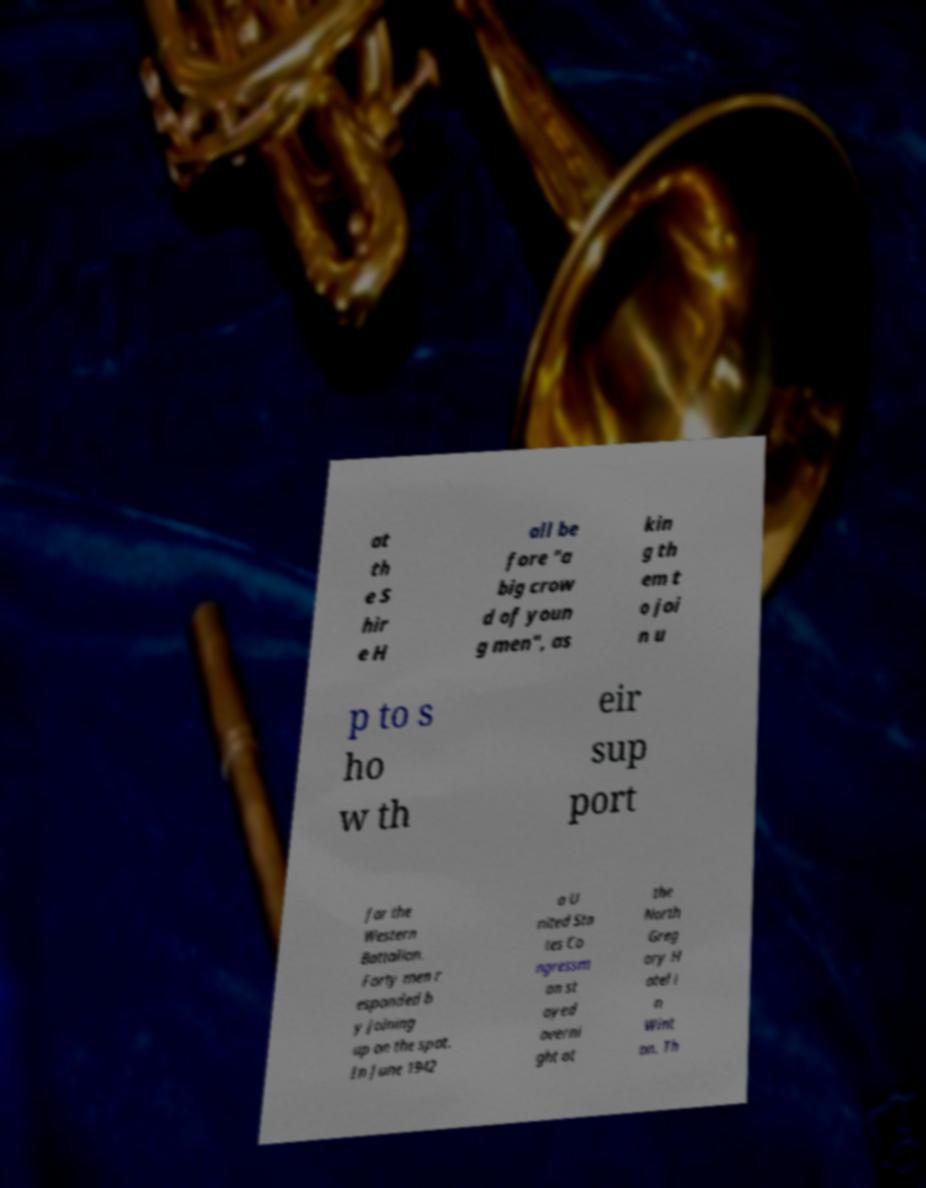Could you extract and type out the text from this image? at th e S hir e H all be fore "a big crow d of youn g men", as kin g th em t o joi n u p to s ho w th eir sup port for the Western Battalion. Forty men r esponded b y joining up on the spot. In June 1942 a U nited Sta tes Co ngressm an st ayed overni ght at the North Greg ory H otel i n Wint on. Th 